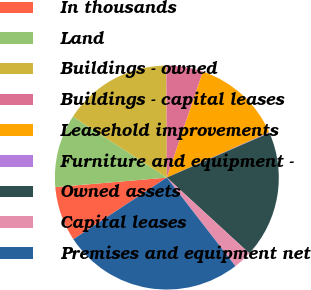Convert chart. <chart><loc_0><loc_0><loc_500><loc_500><pie_chart><fcel>In thousands<fcel>Land<fcel>Buildings - owned<fcel>Buildings - capital leases<fcel>Leasehold improvements<fcel>Furniture and equipment -<fcel>Owned assets<fcel>Capital leases<fcel>Premises and equipment net<nl><fcel>7.92%<fcel>10.53%<fcel>15.76%<fcel>5.3%<fcel>13.14%<fcel>0.08%<fcel>18.37%<fcel>2.69%<fcel>26.21%<nl></chart> 